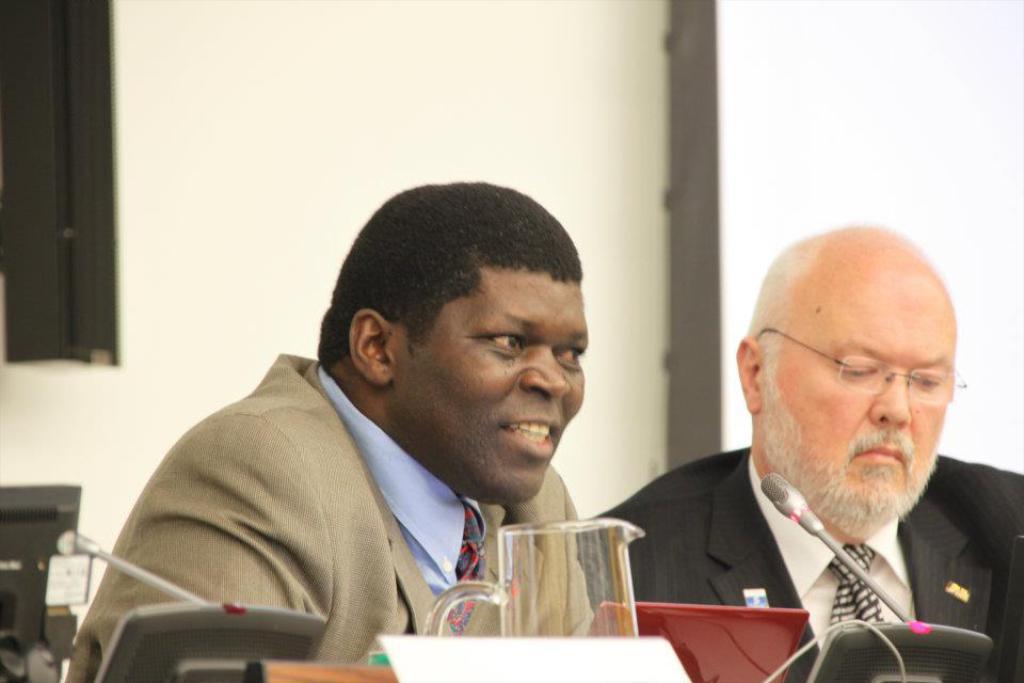Could you give a brief overview of what you see in this image? The man on the left corner of the picture wearing blue shirt is sitting on the chair and he is smiling. Beside him, the man in white shirt and black blazer is sitting on the chair. In front of them, we see a glass jar, microphone and a name board. Behind them, we see a white color board and a wall in white color. On the left corner of the picture, we see a window in brown color. 